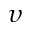<formula> <loc_0><loc_0><loc_500><loc_500>\upsilon</formula> 